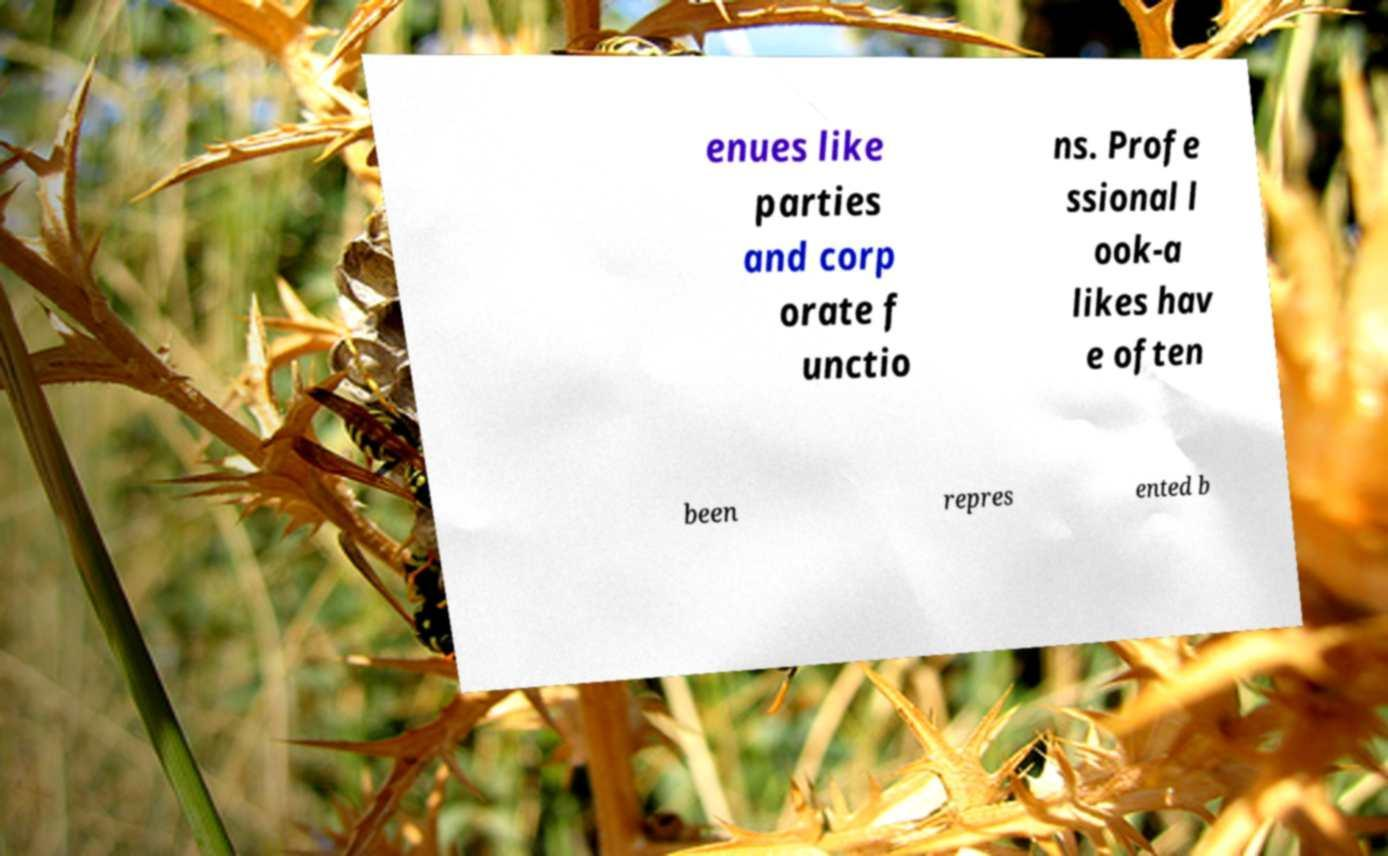Could you extract and type out the text from this image? enues like parties and corp orate f unctio ns. Profe ssional l ook-a likes hav e often been repres ented b 